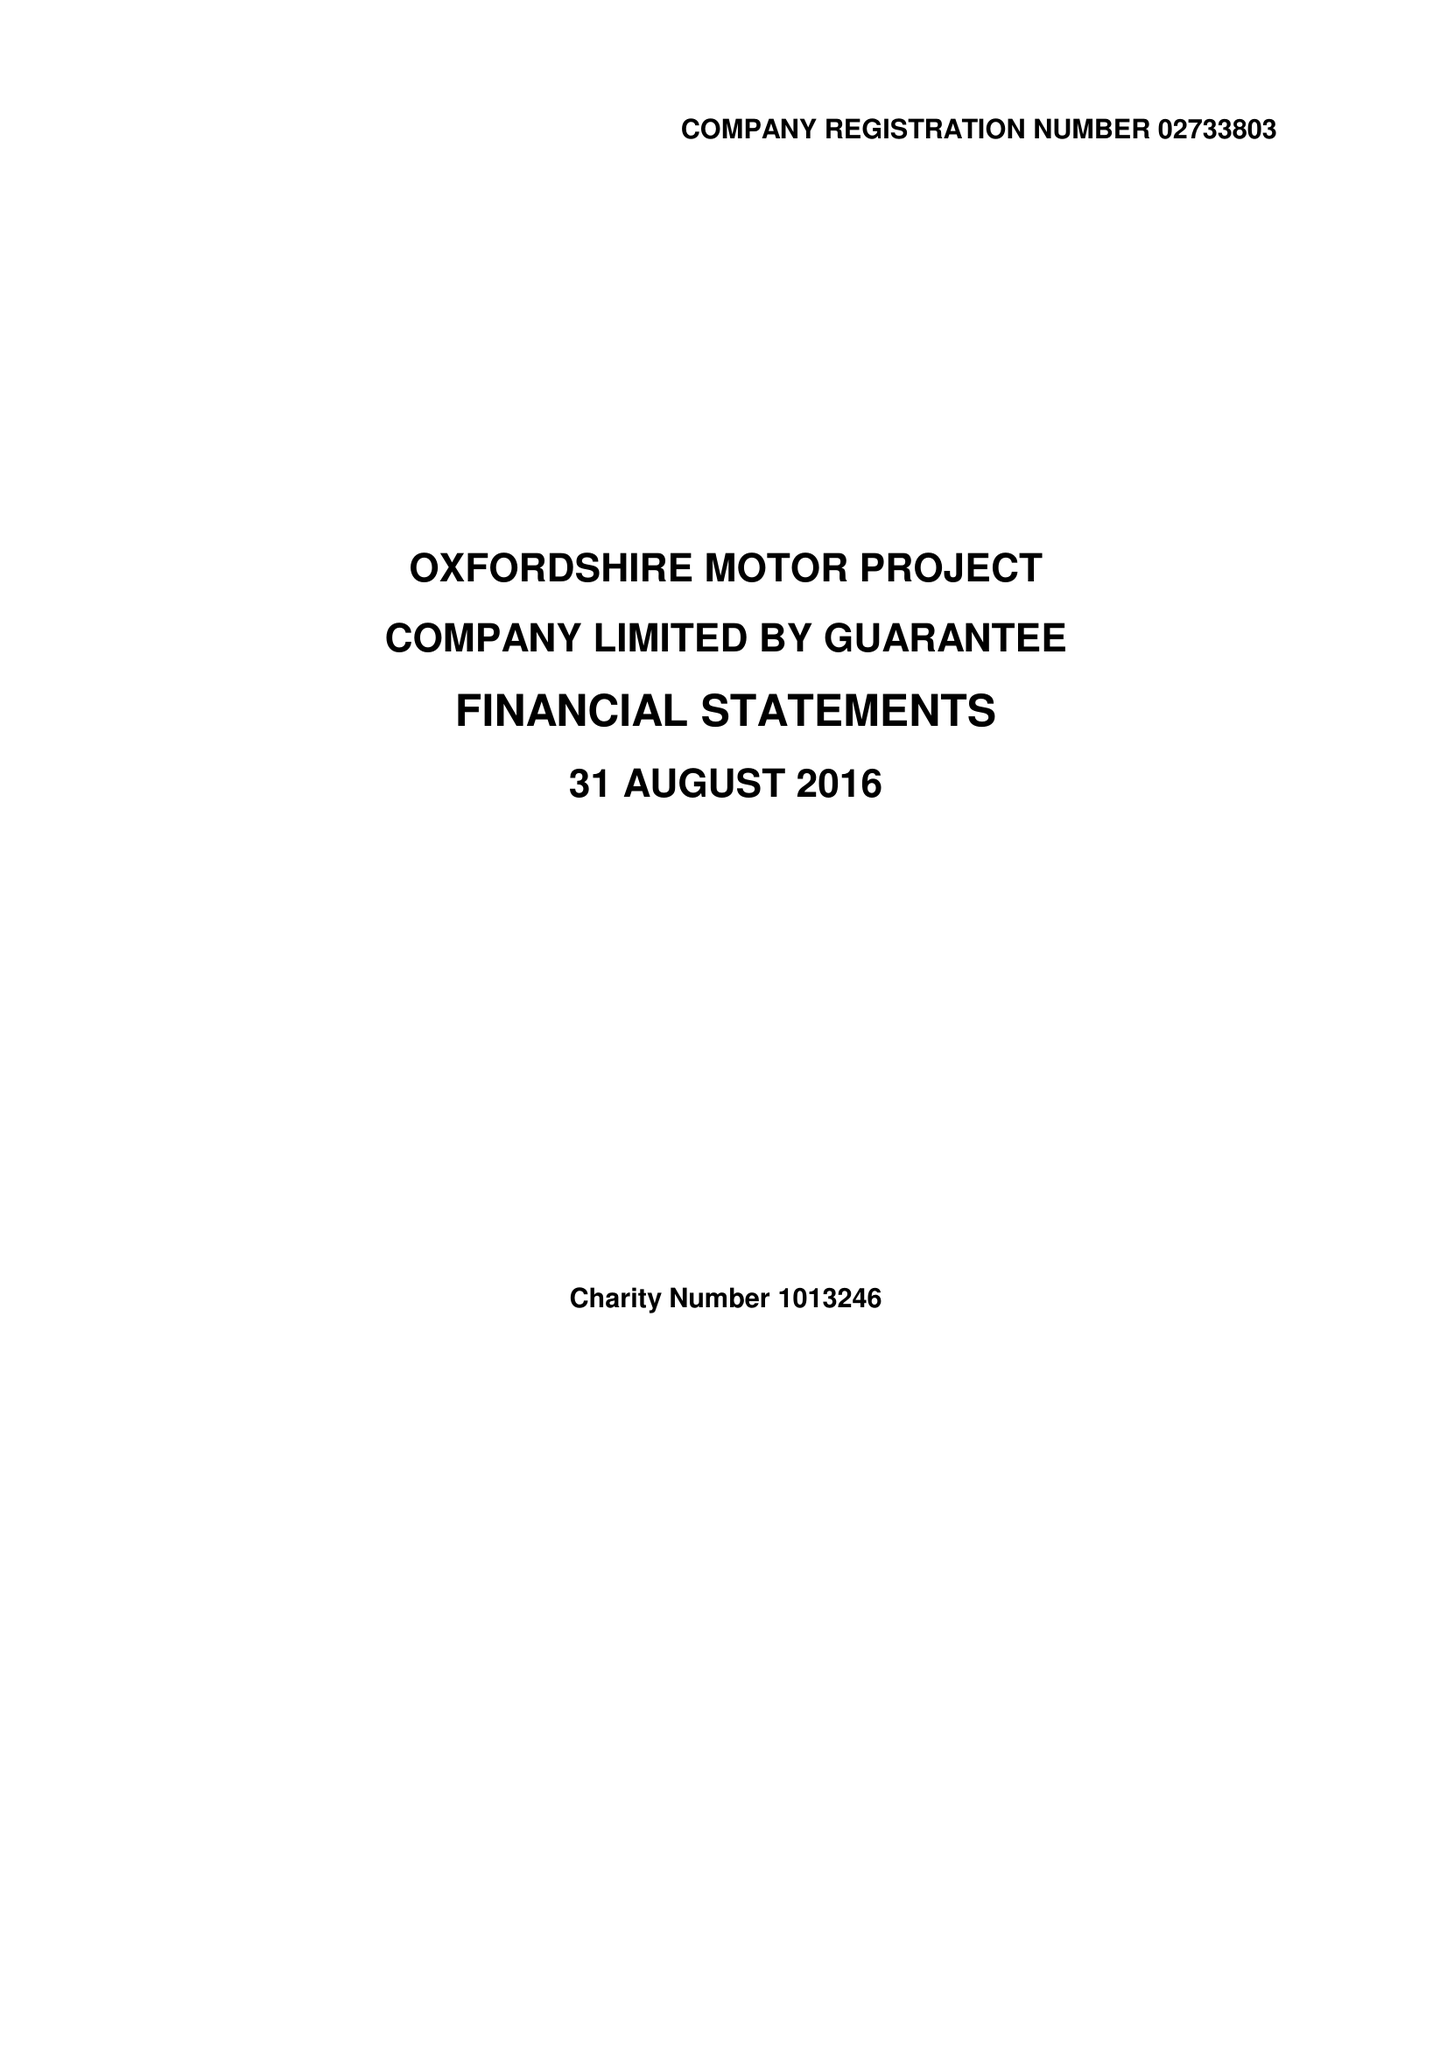What is the value for the charity_name?
Answer the question using a single word or phrase. Oxfordshire Motor Project 